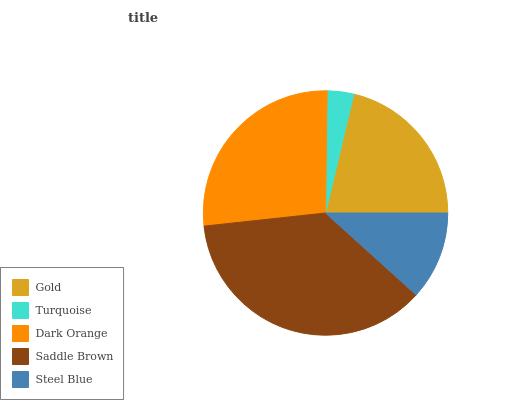Is Turquoise the minimum?
Answer yes or no. Yes. Is Saddle Brown the maximum?
Answer yes or no. Yes. Is Dark Orange the minimum?
Answer yes or no. No. Is Dark Orange the maximum?
Answer yes or no. No. Is Dark Orange greater than Turquoise?
Answer yes or no. Yes. Is Turquoise less than Dark Orange?
Answer yes or no. Yes. Is Turquoise greater than Dark Orange?
Answer yes or no. No. Is Dark Orange less than Turquoise?
Answer yes or no. No. Is Gold the high median?
Answer yes or no. Yes. Is Gold the low median?
Answer yes or no. Yes. Is Turquoise the high median?
Answer yes or no. No. Is Turquoise the low median?
Answer yes or no. No. 